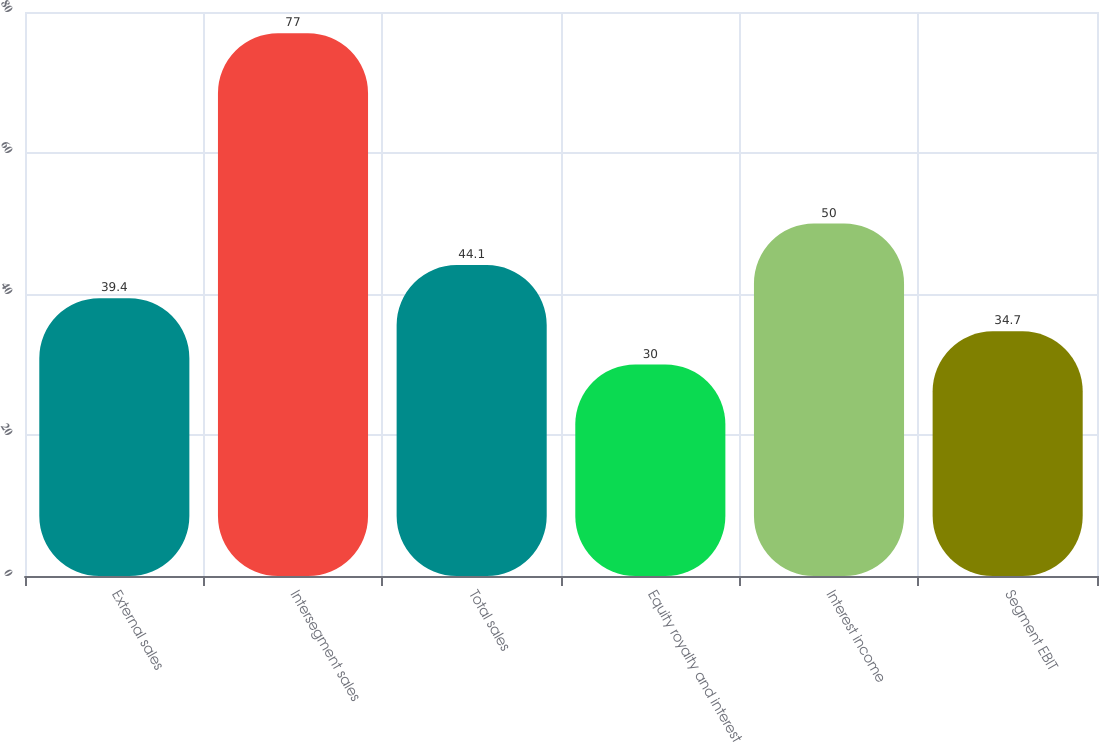<chart> <loc_0><loc_0><loc_500><loc_500><bar_chart><fcel>External sales<fcel>Intersegment sales<fcel>Total sales<fcel>Equity royalty and interest<fcel>Interest income<fcel>Segment EBIT<nl><fcel>39.4<fcel>77<fcel>44.1<fcel>30<fcel>50<fcel>34.7<nl></chart> 